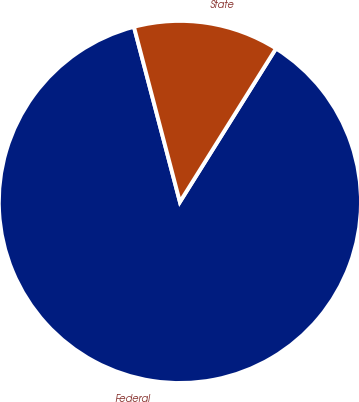Convert chart. <chart><loc_0><loc_0><loc_500><loc_500><pie_chart><fcel>Federal<fcel>State<nl><fcel>87.01%<fcel>12.99%<nl></chart> 